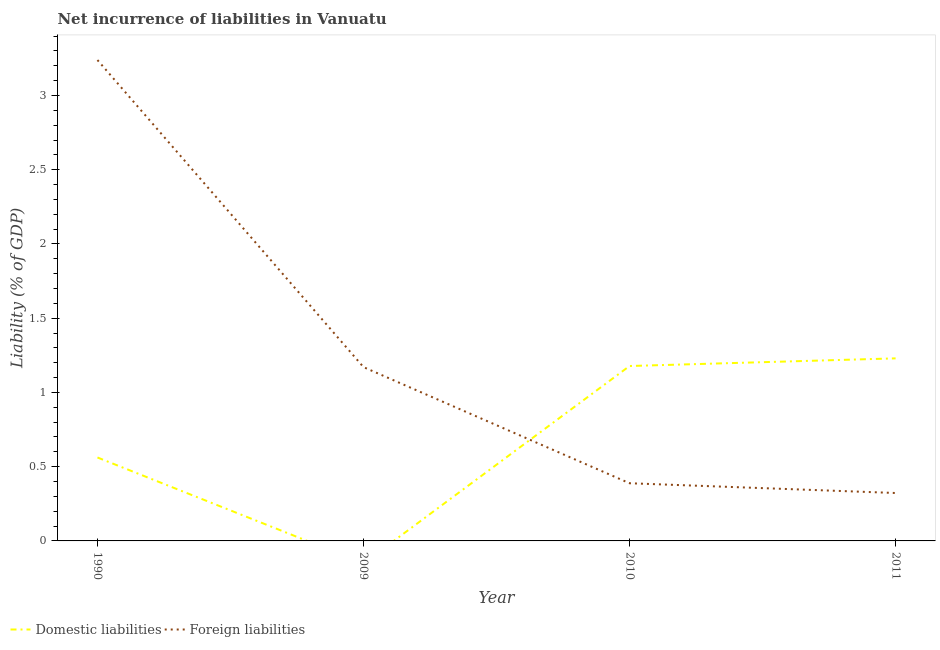How many different coloured lines are there?
Offer a terse response. 2. What is the incurrence of foreign liabilities in 2009?
Keep it short and to the point. 1.17. Across all years, what is the maximum incurrence of domestic liabilities?
Your answer should be very brief. 1.23. In which year was the incurrence of domestic liabilities maximum?
Ensure brevity in your answer.  2011. What is the total incurrence of foreign liabilities in the graph?
Offer a terse response. 5.12. What is the difference between the incurrence of foreign liabilities in 2009 and that in 2011?
Keep it short and to the point. 0.85. What is the difference between the incurrence of foreign liabilities in 2009 and the incurrence of domestic liabilities in 2010?
Offer a terse response. -0.01. What is the average incurrence of domestic liabilities per year?
Keep it short and to the point. 0.74. In the year 1990, what is the difference between the incurrence of domestic liabilities and incurrence of foreign liabilities?
Your answer should be very brief. -2.68. In how many years, is the incurrence of foreign liabilities greater than 1.7 %?
Offer a terse response. 1. What is the ratio of the incurrence of domestic liabilities in 1990 to that in 2011?
Keep it short and to the point. 0.46. Is the incurrence of foreign liabilities in 2009 less than that in 2011?
Provide a short and direct response. No. Is the difference between the incurrence of domestic liabilities in 1990 and 2011 greater than the difference between the incurrence of foreign liabilities in 1990 and 2011?
Keep it short and to the point. No. What is the difference between the highest and the second highest incurrence of foreign liabilities?
Provide a succinct answer. 2.07. What is the difference between the highest and the lowest incurrence of domestic liabilities?
Provide a succinct answer. 1.23. In how many years, is the incurrence of foreign liabilities greater than the average incurrence of foreign liabilities taken over all years?
Provide a succinct answer. 1. Does the incurrence of foreign liabilities monotonically increase over the years?
Make the answer very short. No. How many lines are there?
Offer a very short reply. 2. How many years are there in the graph?
Your answer should be compact. 4. Are the values on the major ticks of Y-axis written in scientific E-notation?
Make the answer very short. No. Does the graph contain any zero values?
Provide a succinct answer. Yes. Where does the legend appear in the graph?
Ensure brevity in your answer.  Bottom left. How are the legend labels stacked?
Your response must be concise. Horizontal. What is the title of the graph?
Offer a terse response. Net incurrence of liabilities in Vanuatu. Does "National Tourists" appear as one of the legend labels in the graph?
Ensure brevity in your answer.  No. What is the label or title of the Y-axis?
Ensure brevity in your answer.  Liability (% of GDP). What is the Liability (% of GDP) in Domestic liabilities in 1990?
Make the answer very short. 0.56. What is the Liability (% of GDP) in Foreign liabilities in 1990?
Make the answer very short. 3.24. What is the Liability (% of GDP) of Foreign liabilities in 2009?
Provide a short and direct response. 1.17. What is the Liability (% of GDP) in Domestic liabilities in 2010?
Your response must be concise. 1.18. What is the Liability (% of GDP) in Foreign liabilities in 2010?
Provide a succinct answer. 0.39. What is the Liability (% of GDP) of Domestic liabilities in 2011?
Provide a short and direct response. 1.23. What is the Liability (% of GDP) of Foreign liabilities in 2011?
Your answer should be very brief. 0.32. Across all years, what is the maximum Liability (% of GDP) of Domestic liabilities?
Ensure brevity in your answer.  1.23. Across all years, what is the maximum Liability (% of GDP) in Foreign liabilities?
Provide a succinct answer. 3.24. Across all years, what is the minimum Liability (% of GDP) of Foreign liabilities?
Offer a terse response. 0.32. What is the total Liability (% of GDP) in Domestic liabilities in the graph?
Your answer should be very brief. 2.97. What is the total Liability (% of GDP) in Foreign liabilities in the graph?
Your response must be concise. 5.12. What is the difference between the Liability (% of GDP) in Foreign liabilities in 1990 and that in 2009?
Ensure brevity in your answer.  2.07. What is the difference between the Liability (% of GDP) of Domestic liabilities in 1990 and that in 2010?
Provide a short and direct response. -0.62. What is the difference between the Liability (% of GDP) in Foreign liabilities in 1990 and that in 2010?
Provide a short and direct response. 2.85. What is the difference between the Liability (% of GDP) in Domestic liabilities in 1990 and that in 2011?
Provide a succinct answer. -0.67. What is the difference between the Liability (% of GDP) in Foreign liabilities in 1990 and that in 2011?
Offer a terse response. 2.92. What is the difference between the Liability (% of GDP) in Foreign liabilities in 2009 and that in 2010?
Ensure brevity in your answer.  0.78. What is the difference between the Liability (% of GDP) of Foreign liabilities in 2009 and that in 2011?
Offer a terse response. 0.85. What is the difference between the Liability (% of GDP) of Domestic liabilities in 2010 and that in 2011?
Your response must be concise. -0.05. What is the difference between the Liability (% of GDP) in Foreign liabilities in 2010 and that in 2011?
Offer a terse response. 0.07. What is the difference between the Liability (% of GDP) in Domestic liabilities in 1990 and the Liability (% of GDP) in Foreign liabilities in 2009?
Offer a terse response. -0.61. What is the difference between the Liability (% of GDP) of Domestic liabilities in 1990 and the Liability (% of GDP) of Foreign liabilities in 2010?
Your answer should be compact. 0.17. What is the difference between the Liability (% of GDP) of Domestic liabilities in 1990 and the Liability (% of GDP) of Foreign liabilities in 2011?
Provide a succinct answer. 0.24. What is the difference between the Liability (% of GDP) in Domestic liabilities in 2010 and the Liability (% of GDP) in Foreign liabilities in 2011?
Make the answer very short. 0.86. What is the average Liability (% of GDP) of Domestic liabilities per year?
Provide a short and direct response. 0.74. What is the average Liability (% of GDP) in Foreign liabilities per year?
Make the answer very short. 1.28. In the year 1990, what is the difference between the Liability (% of GDP) of Domestic liabilities and Liability (% of GDP) of Foreign liabilities?
Offer a very short reply. -2.68. In the year 2010, what is the difference between the Liability (% of GDP) in Domestic liabilities and Liability (% of GDP) in Foreign liabilities?
Offer a very short reply. 0.79. In the year 2011, what is the difference between the Liability (% of GDP) in Domestic liabilities and Liability (% of GDP) in Foreign liabilities?
Give a very brief answer. 0.91. What is the ratio of the Liability (% of GDP) of Foreign liabilities in 1990 to that in 2009?
Provide a succinct answer. 2.77. What is the ratio of the Liability (% of GDP) in Domestic liabilities in 1990 to that in 2010?
Your answer should be very brief. 0.48. What is the ratio of the Liability (% of GDP) in Foreign liabilities in 1990 to that in 2010?
Provide a short and direct response. 8.34. What is the ratio of the Liability (% of GDP) of Domestic liabilities in 1990 to that in 2011?
Provide a succinct answer. 0.46. What is the ratio of the Liability (% of GDP) of Foreign liabilities in 1990 to that in 2011?
Give a very brief answer. 10.04. What is the ratio of the Liability (% of GDP) in Foreign liabilities in 2009 to that in 2010?
Your answer should be very brief. 3.01. What is the ratio of the Liability (% of GDP) of Foreign liabilities in 2009 to that in 2011?
Your answer should be very brief. 3.63. What is the ratio of the Liability (% of GDP) in Domestic liabilities in 2010 to that in 2011?
Ensure brevity in your answer.  0.96. What is the ratio of the Liability (% of GDP) in Foreign liabilities in 2010 to that in 2011?
Offer a terse response. 1.2. What is the difference between the highest and the second highest Liability (% of GDP) of Domestic liabilities?
Provide a succinct answer. 0.05. What is the difference between the highest and the second highest Liability (% of GDP) of Foreign liabilities?
Keep it short and to the point. 2.07. What is the difference between the highest and the lowest Liability (% of GDP) of Domestic liabilities?
Keep it short and to the point. 1.23. What is the difference between the highest and the lowest Liability (% of GDP) in Foreign liabilities?
Offer a terse response. 2.92. 